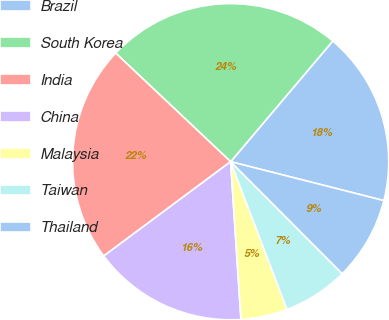Convert chart to OTSL. <chart><loc_0><loc_0><loc_500><loc_500><pie_chart><fcel>Brazil<fcel>South Korea<fcel>India<fcel>China<fcel>Malaysia<fcel>Taiwan<fcel>Thailand<nl><fcel>17.78%<fcel>24.13%<fcel>22.22%<fcel>15.87%<fcel>4.76%<fcel>6.67%<fcel>8.57%<nl></chart> 